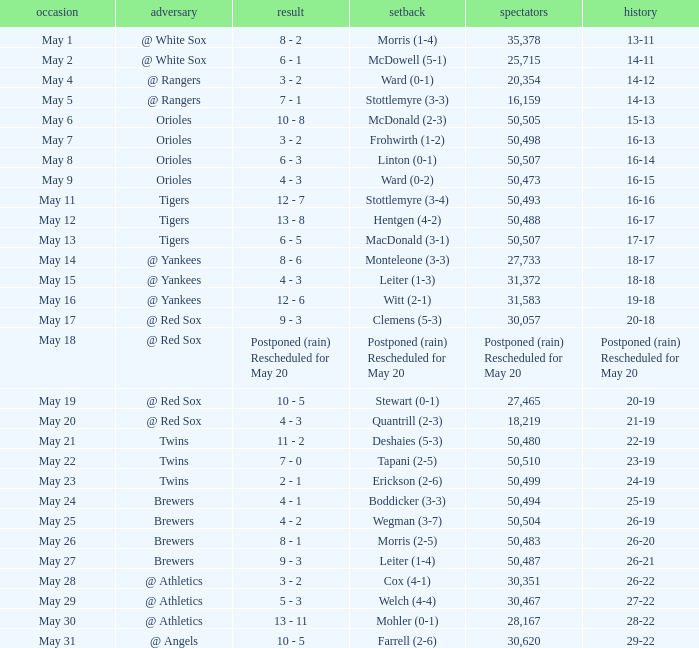What team did they lose to when they had a 28-22 record? Mohler (0-1). 